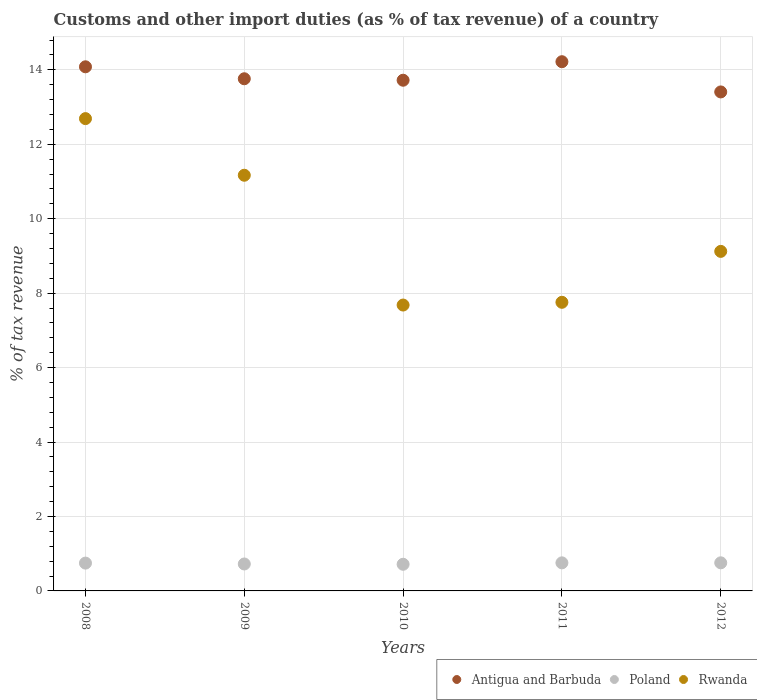How many different coloured dotlines are there?
Provide a succinct answer. 3. Is the number of dotlines equal to the number of legend labels?
Keep it short and to the point. Yes. What is the percentage of tax revenue from customs in Antigua and Barbuda in 2011?
Offer a very short reply. 14.22. Across all years, what is the maximum percentage of tax revenue from customs in Rwanda?
Ensure brevity in your answer.  12.69. Across all years, what is the minimum percentage of tax revenue from customs in Rwanda?
Your answer should be very brief. 7.68. In which year was the percentage of tax revenue from customs in Poland minimum?
Your answer should be compact. 2010. What is the total percentage of tax revenue from customs in Rwanda in the graph?
Make the answer very short. 48.41. What is the difference between the percentage of tax revenue from customs in Antigua and Barbuda in 2010 and that in 2012?
Your answer should be very brief. 0.31. What is the difference between the percentage of tax revenue from customs in Poland in 2010 and the percentage of tax revenue from customs in Rwanda in 2009?
Keep it short and to the point. -10.45. What is the average percentage of tax revenue from customs in Rwanda per year?
Provide a succinct answer. 9.68. In the year 2011, what is the difference between the percentage of tax revenue from customs in Poland and percentage of tax revenue from customs in Rwanda?
Provide a succinct answer. -7. In how many years, is the percentage of tax revenue from customs in Poland greater than 0.8 %?
Make the answer very short. 0. What is the ratio of the percentage of tax revenue from customs in Poland in 2010 to that in 2011?
Keep it short and to the point. 0.95. Is the percentage of tax revenue from customs in Antigua and Barbuda in 2008 less than that in 2011?
Offer a terse response. Yes. Is the difference between the percentage of tax revenue from customs in Poland in 2010 and 2012 greater than the difference between the percentage of tax revenue from customs in Rwanda in 2010 and 2012?
Provide a short and direct response. Yes. What is the difference between the highest and the second highest percentage of tax revenue from customs in Rwanda?
Your response must be concise. 1.52. What is the difference between the highest and the lowest percentage of tax revenue from customs in Poland?
Your answer should be compact. 0.04. In how many years, is the percentage of tax revenue from customs in Antigua and Barbuda greater than the average percentage of tax revenue from customs in Antigua and Barbuda taken over all years?
Ensure brevity in your answer.  2. Is it the case that in every year, the sum of the percentage of tax revenue from customs in Antigua and Barbuda and percentage of tax revenue from customs in Rwanda  is greater than the percentage of tax revenue from customs in Poland?
Your answer should be compact. Yes. How many years are there in the graph?
Your answer should be compact. 5. What is the difference between two consecutive major ticks on the Y-axis?
Ensure brevity in your answer.  2. Does the graph contain any zero values?
Your answer should be very brief. No. How many legend labels are there?
Your answer should be very brief. 3. How are the legend labels stacked?
Your answer should be very brief. Horizontal. What is the title of the graph?
Give a very brief answer. Customs and other import duties (as % of tax revenue) of a country. Does "Switzerland" appear as one of the legend labels in the graph?
Ensure brevity in your answer.  No. What is the label or title of the X-axis?
Ensure brevity in your answer.  Years. What is the label or title of the Y-axis?
Ensure brevity in your answer.  % of tax revenue. What is the % of tax revenue in Antigua and Barbuda in 2008?
Offer a very short reply. 14.08. What is the % of tax revenue in Poland in 2008?
Ensure brevity in your answer.  0.75. What is the % of tax revenue of Rwanda in 2008?
Provide a short and direct response. 12.69. What is the % of tax revenue in Antigua and Barbuda in 2009?
Your answer should be very brief. 13.76. What is the % of tax revenue of Poland in 2009?
Provide a succinct answer. 0.72. What is the % of tax revenue of Rwanda in 2009?
Provide a short and direct response. 11.17. What is the % of tax revenue in Antigua and Barbuda in 2010?
Provide a succinct answer. 13.72. What is the % of tax revenue of Poland in 2010?
Keep it short and to the point. 0.72. What is the % of tax revenue of Rwanda in 2010?
Provide a succinct answer. 7.68. What is the % of tax revenue of Antigua and Barbuda in 2011?
Make the answer very short. 14.22. What is the % of tax revenue of Poland in 2011?
Offer a very short reply. 0.75. What is the % of tax revenue in Rwanda in 2011?
Provide a succinct answer. 7.75. What is the % of tax revenue of Antigua and Barbuda in 2012?
Offer a very short reply. 13.41. What is the % of tax revenue in Poland in 2012?
Keep it short and to the point. 0.75. What is the % of tax revenue in Rwanda in 2012?
Provide a short and direct response. 9.12. Across all years, what is the maximum % of tax revenue in Antigua and Barbuda?
Provide a short and direct response. 14.22. Across all years, what is the maximum % of tax revenue in Poland?
Ensure brevity in your answer.  0.75. Across all years, what is the maximum % of tax revenue of Rwanda?
Provide a succinct answer. 12.69. Across all years, what is the minimum % of tax revenue in Antigua and Barbuda?
Your answer should be very brief. 13.41. Across all years, what is the minimum % of tax revenue of Poland?
Your response must be concise. 0.72. Across all years, what is the minimum % of tax revenue of Rwanda?
Keep it short and to the point. 7.68. What is the total % of tax revenue in Antigua and Barbuda in the graph?
Make the answer very short. 69.19. What is the total % of tax revenue of Poland in the graph?
Provide a succinct answer. 3.7. What is the total % of tax revenue in Rwanda in the graph?
Your response must be concise. 48.41. What is the difference between the % of tax revenue of Antigua and Barbuda in 2008 and that in 2009?
Your answer should be very brief. 0.32. What is the difference between the % of tax revenue in Poland in 2008 and that in 2009?
Your answer should be compact. 0.02. What is the difference between the % of tax revenue in Rwanda in 2008 and that in 2009?
Ensure brevity in your answer.  1.52. What is the difference between the % of tax revenue in Antigua and Barbuda in 2008 and that in 2010?
Keep it short and to the point. 0.36. What is the difference between the % of tax revenue of Poland in 2008 and that in 2010?
Ensure brevity in your answer.  0.03. What is the difference between the % of tax revenue in Rwanda in 2008 and that in 2010?
Make the answer very short. 5.01. What is the difference between the % of tax revenue of Antigua and Barbuda in 2008 and that in 2011?
Offer a terse response. -0.14. What is the difference between the % of tax revenue in Poland in 2008 and that in 2011?
Offer a terse response. -0.01. What is the difference between the % of tax revenue of Rwanda in 2008 and that in 2011?
Make the answer very short. 4.93. What is the difference between the % of tax revenue of Antigua and Barbuda in 2008 and that in 2012?
Offer a terse response. 0.68. What is the difference between the % of tax revenue of Poland in 2008 and that in 2012?
Your answer should be very brief. -0.01. What is the difference between the % of tax revenue in Rwanda in 2008 and that in 2012?
Give a very brief answer. 3.57. What is the difference between the % of tax revenue in Antigua and Barbuda in 2009 and that in 2010?
Provide a succinct answer. 0.04. What is the difference between the % of tax revenue of Poland in 2009 and that in 2010?
Offer a very short reply. 0.01. What is the difference between the % of tax revenue in Rwanda in 2009 and that in 2010?
Provide a short and direct response. 3.49. What is the difference between the % of tax revenue of Antigua and Barbuda in 2009 and that in 2011?
Your response must be concise. -0.46. What is the difference between the % of tax revenue in Poland in 2009 and that in 2011?
Give a very brief answer. -0.03. What is the difference between the % of tax revenue in Rwanda in 2009 and that in 2011?
Give a very brief answer. 3.41. What is the difference between the % of tax revenue of Antigua and Barbuda in 2009 and that in 2012?
Make the answer very short. 0.35. What is the difference between the % of tax revenue in Poland in 2009 and that in 2012?
Make the answer very short. -0.03. What is the difference between the % of tax revenue in Rwanda in 2009 and that in 2012?
Your response must be concise. 2.05. What is the difference between the % of tax revenue in Antigua and Barbuda in 2010 and that in 2011?
Give a very brief answer. -0.5. What is the difference between the % of tax revenue of Poland in 2010 and that in 2011?
Provide a short and direct response. -0.04. What is the difference between the % of tax revenue in Rwanda in 2010 and that in 2011?
Provide a succinct answer. -0.07. What is the difference between the % of tax revenue in Antigua and Barbuda in 2010 and that in 2012?
Give a very brief answer. 0.31. What is the difference between the % of tax revenue in Poland in 2010 and that in 2012?
Keep it short and to the point. -0.04. What is the difference between the % of tax revenue of Rwanda in 2010 and that in 2012?
Ensure brevity in your answer.  -1.44. What is the difference between the % of tax revenue of Antigua and Barbuda in 2011 and that in 2012?
Offer a very short reply. 0.81. What is the difference between the % of tax revenue in Poland in 2011 and that in 2012?
Provide a short and direct response. -0. What is the difference between the % of tax revenue of Rwanda in 2011 and that in 2012?
Provide a succinct answer. -1.37. What is the difference between the % of tax revenue of Antigua and Barbuda in 2008 and the % of tax revenue of Poland in 2009?
Make the answer very short. 13.36. What is the difference between the % of tax revenue in Antigua and Barbuda in 2008 and the % of tax revenue in Rwanda in 2009?
Ensure brevity in your answer.  2.91. What is the difference between the % of tax revenue in Poland in 2008 and the % of tax revenue in Rwanda in 2009?
Keep it short and to the point. -10.42. What is the difference between the % of tax revenue of Antigua and Barbuda in 2008 and the % of tax revenue of Poland in 2010?
Give a very brief answer. 13.37. What is the difference between the % of tax revenue in Antigua and Barbuda in 2008 and the % of tax revenue in Rwanda in 2010?
Your answer should be very brief. 6.4. What is the difference between the % of tax revenue in Poland in 2008 and the % of tax revenue in Rwanda in 2010?
Offer a terse response. -6.93. What is the difference between the % of tax revenue of Antigua and Barbuda in 2008 and the % of tax revenue of Poland in 2011?
Keep it short and to the point. 13.33. What is the difference between the % of tax revenue of Antigua and Barbuda in 2008 and the % of tax revenue of Rwanda in 2011?
Your response must be concise. 6.33. What is the difference between the % of tax revenue in Poland in 2008 and the % of tax revenue in Rwanda in 2011?
Your answer should be very brief. -7.01. What is the difference between the % of tax revenue in Antigua and Barbuda in 2008 and the % of tax revenue in Poland in 2012?
Offer a very short reply. 13.33. What is the difference between the % of tax revenue in Antigua and Barbuda in 2008 and the % of tax revenue in Rwanda in 2012?
Provide a succinct answer. 4.96. What is the difference between the % of tax revenue of Poland in 2008 and the % of tax revenue of Rwanda in 2012?
Your answer should be very brief. -8.38. What is the difference between the % of tax revenue of Antigua and Barbuda in 2009 and the % of tax revenue of Poland in 2010?
Ensure brevity in your answer.  13.04. What is the difference between the % of tax revenue in Antigua and Barbuda in 2009 and the % of tax revenue in Rwanda in 2010?
Your response must be concise. 6.08. What is the difference between the % of tax revenue in Poland in 2009 and the % of tax revenue in Rwanda in 2010?
Keep it short and to the point. -6.96. What is the difference between the % of tax revenue in Antigua and Barbuda in 2009 and the % of tax revenue in Poland in 2011?
Offer a very short reply. 13.01. What is the difference between the % of tax revenue in Antigua and Barbuda in 2009 and the % of tax revenue in Rwanda in 2011?
Provide a short and direct response. 6.01. What is the difference between the % of tax revenue of Poland in 2009 and the % of tax revenue of Rwanda in 2011?
Ensure brevity in your answer.  -7.03. What is the difference between the % of tax revenue in Antigua and Barbuda in 2009 and the % of tax revenue in Poland in 2012?
Keep it short and to the point. 13.01. What is the difference between the % of tax revenue in Antigua and Barbuda in 2009 and the % of tax revenue in Rwanda in 2012?
Give a very brief answer. 4.64. What is the difference between the % of tax revenue of Poland in 2009 and the % of tax revenue of Rwanda in 2012?
Offer a terse response. -8.4. What is the difference between the % of tax revenue of Antigua and Barbuda in 2010 and the % of tax revenue of Poland in 2011?
Your answer should be very brief. 12.97. What is the difference between the % of tax revenue of Antigua and Barbuda in 2010 and the % of tax revenue of Rwanda in 2011?
Your response must be concise. 5.97. What is the difference between the % of tax revenue of Poland in 2010 and the % of tax revenue of Rwanda in 2011?
Your answer should be very brief. -7.04. What is the difference between the % of tax revenue in Antigua and Barbuda in 2010 and the % of tax revenue in Poland in 2012?
Offer a terse response. 12.97. What is the difference between the % of tax revenue of Antigua and Barbuda in 2010 and the % of tax revenue of Rwanda in 2012?
Offer a very short reply. 4.6. What is the difference between the % of tax revenue of Poland in 2010 and the % of tax revenue of Rwanda in 2012?
Give a very brief answer. -8.41. What is the difference between the % of tax revenue in Antigua and Barbuda in 2011 and the % of tax revenue in Poland in 2012?
Your response must be concise. 13.46. What is the difference between the % of tax revenue in Antigua and Barbuda in 2011 and the % of tax revenue in Rwanda in 2012?
Provide a short and direct response. 5.1. What is the difference between the % of tax revenue of Poland in 2011 and the % of tax revenue of Rwanda in 2012?
Ensure brevity in your answer.  -8.37. What is the average % of tax revenue of Antigua and Barbuda per year?
Ensure brevity in your answer.  13.84. What is the average % of tax revenue of Poland per year?
Your response must be concise. 0.74. What is the average % of tax revenue of Rwanda per year?
Offer a terse response. 9.68. In the year 2008, what is the difference between the % of tax revenue in Antigua and Barbuda and % of tax revenue in Poland?
Your answer should be very brief. 13.33. In the year 2008, what is the difference between the % of tax revenue of Antigua and Barbuda and % of tax revenue of Rwanda?
Your answer should be very brief. 1.39. In the year 2008, what is the difference between the % of tax revenue of Poland and % of tax revenue of Rwanda?
Give a very brief answer. -11.94. In the year 2009, what is the difference between the % of tax revenue of Antigua and Barbuda and % of tax revenue of Poland?
Offer a very short reply. 13.04. In the year 2009, what is the difference between the % of tax revenue in Antigua and Barbuda and % of tax revenue in Rwanda?
Give a very brief answer. 2.59. In the year 2009, what is the difference between the % of tax revenue of Poland and % of tax revenue of Rwanda?
Your response must be concise. -10.44. In the year 2010, what is the difference between the % of tax revenue in Antigua and Barbuda and % of tax revenue in Poland?
Give a very brief answer. 13. In the year 2010, what is the difference between the % of tax revenue in Antigua and Barbuda and % of tax revenue in Rwanda?
Ensure brevity in your answer.  6.04. In the year 2010, what is the difference between the % of tax revenue of Poland and % of tax revenue of Rwanda?
Provide a short and direct response. -6.96. In the year 2011, what is the difference between the % of tax revenue in Antigua and Barbuda and % of tax revenue in Poland?
Your response must be concise. 13.46. In the year 2011, what is the difference between the % of tax revenue in Antigua and Barbuda and % of tax revenue in Rwanda?
Provide a succinct answer. 6.46. In the year 2011, what is the difference between the % of tax revenue in Poland and % of tax revenue in Rwanda?
Ensure brevity in your answer.  -7. In the year 2012, what is the difference between the % of tax revenue in Antigua and Barbuda and % of tax revenue in Poland?
Make the answer very short. 12.65. In the year 2012, what is the difference between the % of tax revenue of Antigua and Barbuda and % of tax revenue of Rwanda?
Offer a terse response. 4.28. In the year 2012, what is the difference between the % of tax revenue in Poland and % of tax revenue in Rwanda?
Provide a succinct answer. -8.37. What is the ratio of the % of tax revenue of Antigua and Barbuda in 2008 to that in 2009?
Your response must be concise. 1.02. What is the ratio of the % of tax revenue in Poland in 2008 to that in 2009?
Ensure brevity in your answer.  1.03. What is the ratio of the % of tax revenue of Rwanda in 2008 to that in 2009?
Make the answer very short. 1.14. What is the ratio of the % of tax revenue in Antigua and Barbuda in 2008 to that in 2010?
Offer a terse response. 1.03. What is the ratio of the % of tax revenue of Poland in 2008 to that in 2010?
Make the answer very short. 1.04. What is the ratio of the % of tax revenue of Rwanda in 2008 to that in 2010?
Your answer should be compact. 1.65. What is the ratio of the % of tax revenue of Poland in 2008 to that in 2011?
Your response must be concise. 0.99. What is the ratio of the % of tax revenue of Rwanda in 2008 to that in 2011?
Your answer should be very brief. 1.64. What is the ratio of the % of tax revenue in Antigua and Barbuda in 2008 to that in 2012?
Give a very brief answer. 1.05. What is the ratio of the % of tax revenue in Rwanda in 2008 to that in 2012?
Your answer should be compact. 1.39. What is the ratio of the % of tax revenue in Antigua and Barbuda in 2009 to that in 2010?
Ensure brevity in your answer.  1. What is the ratio of the % of tax revenue in Poland in 2009 to that in 2010?
Your response must be concise. 1.01. What is the ratio of the % of tax revenue of Rwanda in 2009 to that in 2010?
Ensure brevity in your answer.  1.45. What is the ratio of the % of tax revenue in Antigua and Barbuda in 2009 to that in 2011?
Offer a terse response. 0.97. What is the ratio of the % of tax revenue of Poland in 2009 to that in 2011?
Provide a succinct answer. 0.96. What is the ratio of the % of tax revenue in Rwanda in 2009 to that in 2011?
Offer a very short reply. 1.44. What is the ratio of the % of tax revenue in Antigua and Barbuda in 2009 to that in 2012?
Keep it short and to the point. 1.03. What is the ratio of the % of tax revenue in Poland in 2009 to that in 2012?
Offer a very short reply. 0.96. What is the ratio of the % of tax revenue in Rwanda in 2009 to that in 2012?
Ensure brevity in your answer.  1.22. What is the ratio of the % of tax revenue of Poland in 2010 to that in 2011?
Offer a terse response. 0.95. What is the ratio of the % of tax revenue of Antigua and Barbuda in 2010 to that in 2012?
Offer a very short reply. 1.02. What is the ratio of the % of tax revenue of Poland in 2010 to that in 2012?
Give a very brief answer. 0.95. What is the ratio of the % of tax revenue of Rwanda in 2010 to that in 2012?
Provide a short and direct response. 0.84. What is the ratio of the % of tax revenue in Antigua and Barbuda in 2011 to that in 2012?
Your answer should be compact. 1.06. What is the ratio of the % of tax revenue of Rwanda in 2011 to that in 2012?
Provide a succinct answer. 0.85. What is the difference between the highest and the second highest % of tax revenue of Antigua and Barbuda?
Your answer should be very brief. 0.14. What is the difference between the highest and the second highest % of tax revenue of Poland?
Offer a very short reply. 0. What is the difference between the highest and the second highest % of tax revenue in Rwanda?
Your response must be concise. 1.52. What is the difference between the highest and the lowest % of tax revenue in Antigua and Barbuda?
Give a very brief answer. 0.81. What is the difference between the highest and the lowest % of tax revenue of Poland?
Offer a terse response. 0.04. What is the difference between the highest and the lowest % of tax revenue of Rwanda?
Make the answer very short. 5.01. 